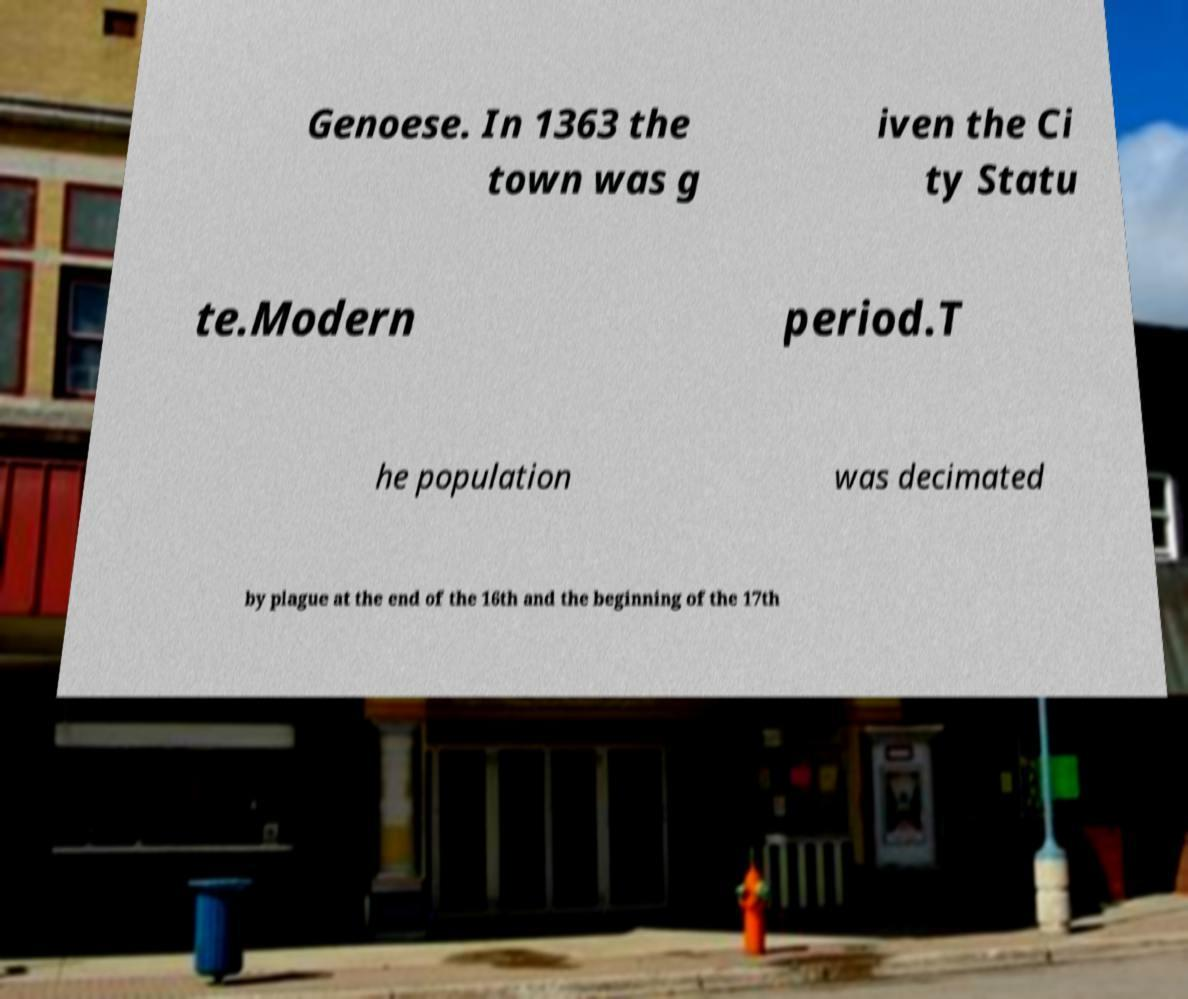There's text embedded in this image that I need extracted. Can you transcribe it verbatim? Genoese. In 1363 the town was g iven the Ci ty Statu te.Modern period.T he population was decimated by plague at the end of the 16th and the beginning of the 17th 